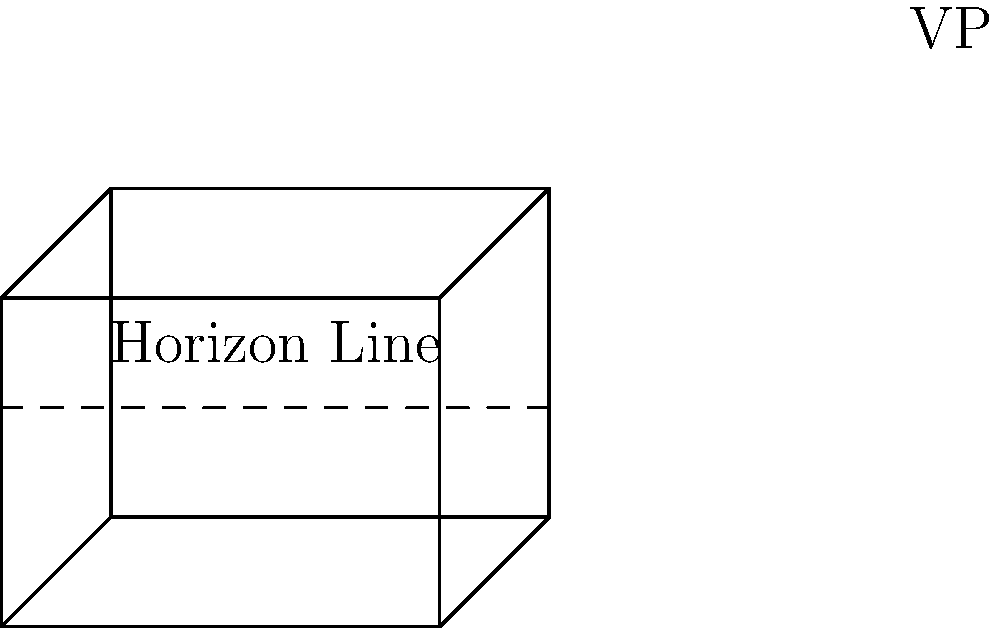In the simple architectural sketch of a cube shown above, what does the dashed line represent, and how does it relate to the vanishing point (VP) labeled in the drawing? To understand this architectural sketch and its elements, let's break it down step-by-step:

1. The sketch shows a cube drawn in one-point perspective.

2. The dashed line in the sketch represents the horizon line. In perspective drawing, the horizon line is an imaginary horizontal line that represents the viewer's eye level.

3. The vanishing point (VP) is labeled on the right side of the sketch, and it lies on the horizon line.

4. In one-point perspective, all lines that are perpendicular to the picture plane converge at the vanishing point.

5. The relationship between the horizon line and the vanishing point is crucial in perspective drawing:
   a) The horizon line always contains the vanishing point(s) in a perspective drawing.
   b) The placement of the horizon line determines the viewer's eye level in relation to the object being drawn.

6. In this sketch, we can see that:
   a) The horizontal edges of the cube remain parallel to the horizon line.
   b) The edges perpendicular to the picture plane converge at the vanishing point on the horizon line.

Understanding this relationship helps artists and designers create accurate and realistic perspective drawings of architectural structures and other objects.
Answer: The dashed line represents the horizon line, which contains the vanishing point (VP) and determines the viewer's eye level in the perspective drawing. 